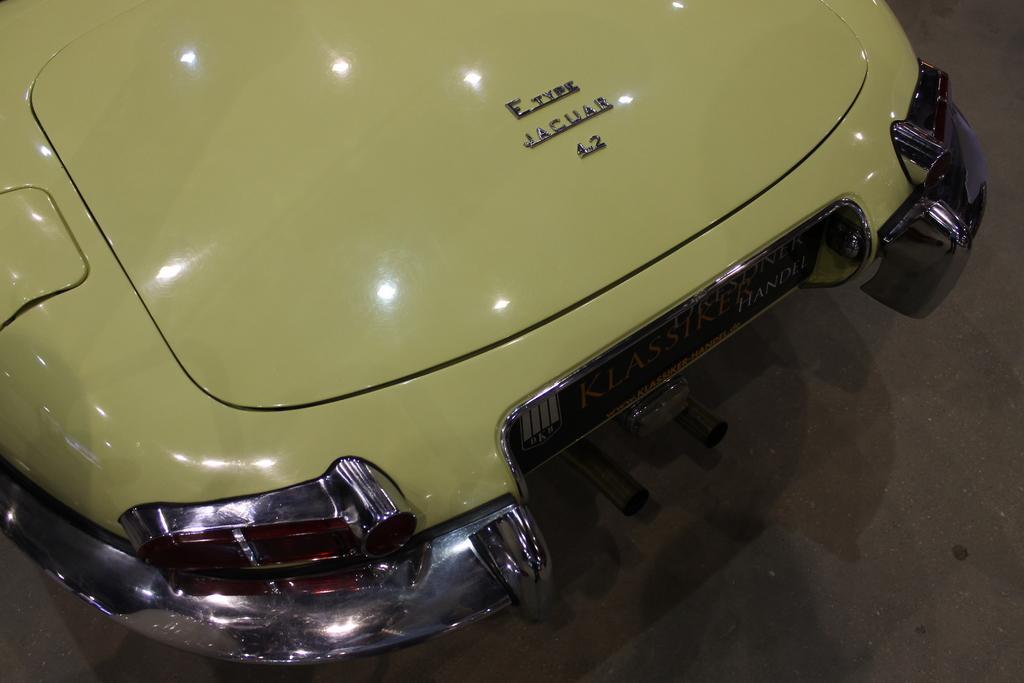How would you summarize this image in a sentence or two? In this image I can see the front part of a vehicle with some text written on it. 